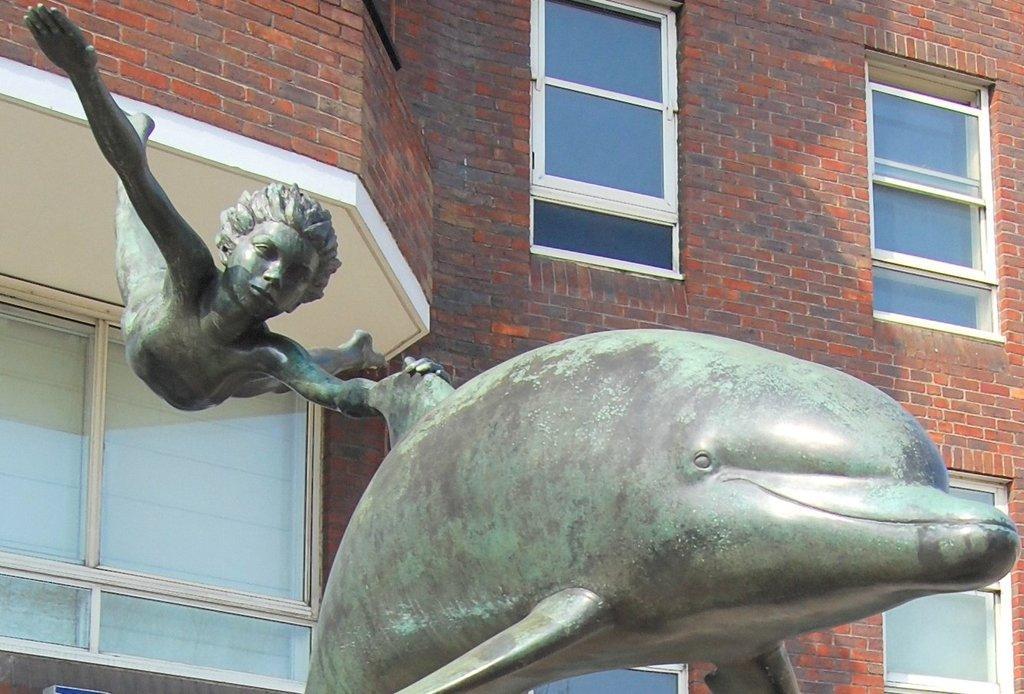In one or two sentences, can you explain what this image depicts? This picture is clicked outside. In the foreground we can see a sculpture of a dolphin and a sculpture of a person in the air. In the background we can see the building and we can see the windows and the brick wall of the building. 